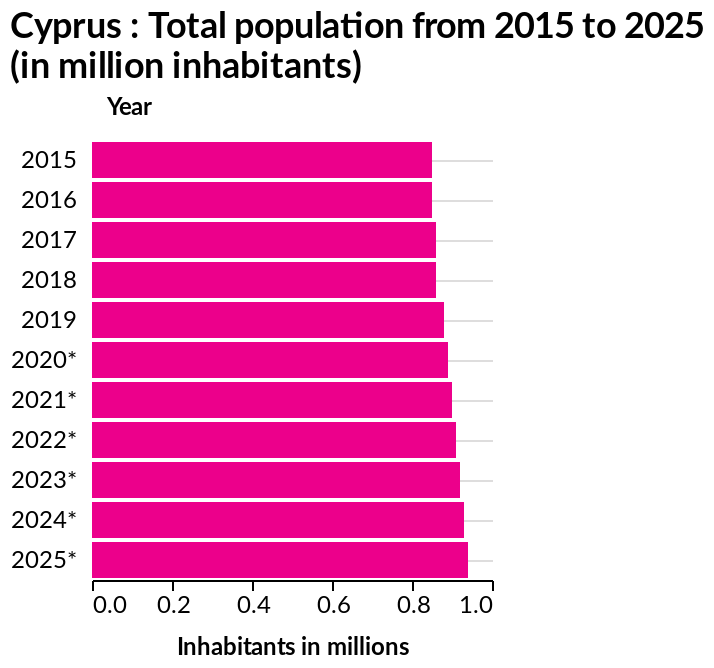<image>
Was there a predicted increase in the total population of Cyprus from 2018 to the following year?  Yes, there was a year on year predicted increase in the total population of Cyprus. What does the x-axis represent in the bar plot?  The x-axis represents the number of inhabitants in millions using a linear scale with a minimum of 0.0 and a maximum of 1.0. please summary the statistics and relations of the chart The total population of Cyprus (in million inhabitants) in 2015 & 2016 stayed the same. It then increased slightly from 2016 to 2017. The total population of Cyprus (in million inhabitants) in 2018 stayed the same as 2017. There was then a year on year increase/predicted increase of the total population of Cyprus (in million inhabitants). 